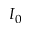<formula> <loc_0><loc_0><loc_500><loc_500>I _ { 0 }</formula> 